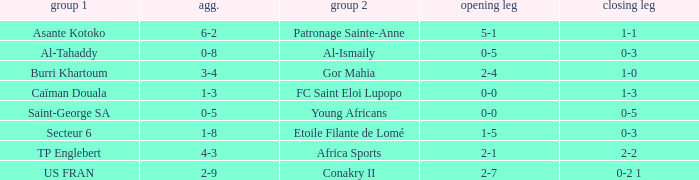What was the 2nd leg score between Patronage Sainte-Anne and Asante Kotoko? 1-1. 